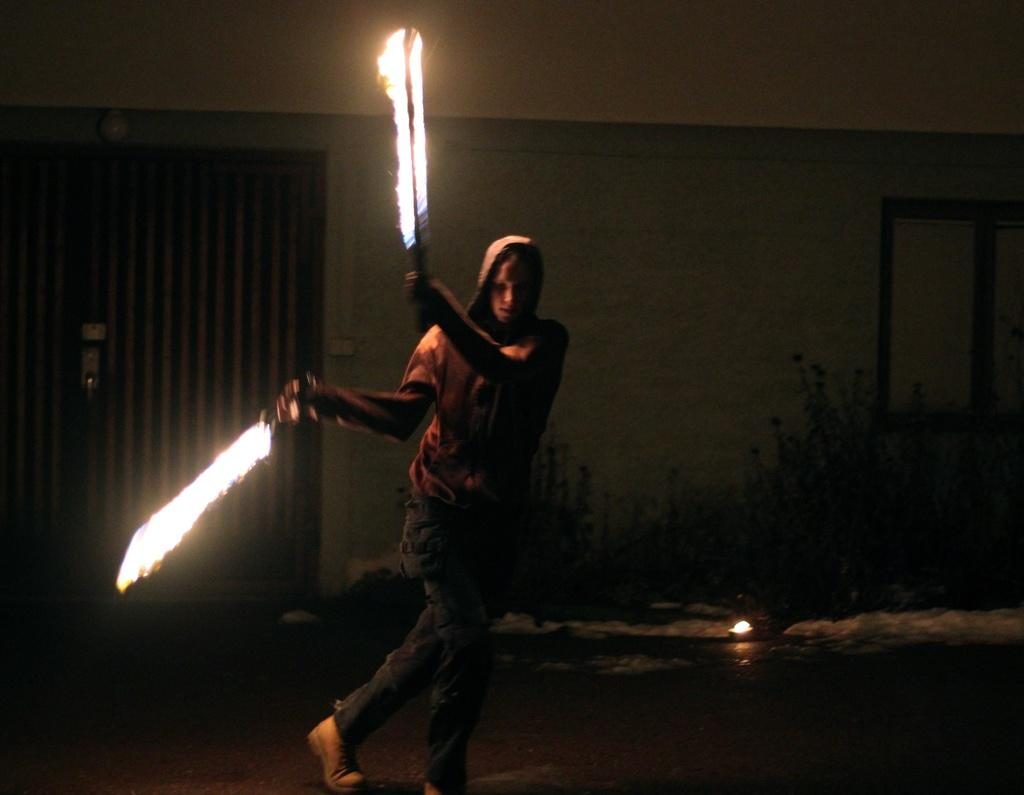What is the person in the foreground holding in their hand? The person in the foreground is holding fire sticks in their hand. What can be seen in the background of the image? There is a building, a door, a window, and houseplants visible in the background. Can you describe the lighting conditions in the image? The image may have been taken during the night, as it appears to be dark. How many babies are visible in the image? There are no babies present in the image. What is the position of the passenger in the image? There is no passenger present in the image. 